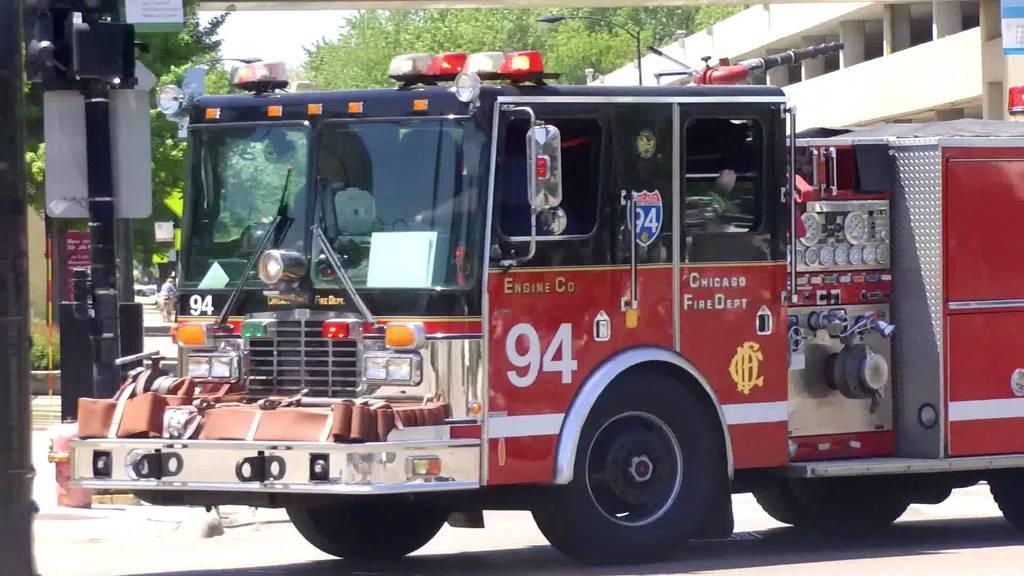Could you give a brief overview of what you see in this image? In this image we can see a vehicle looks like a fire engine on the road, beside the fire engine there is a pole with a board, in the background there is a building, streetlight, few trees and sky. 